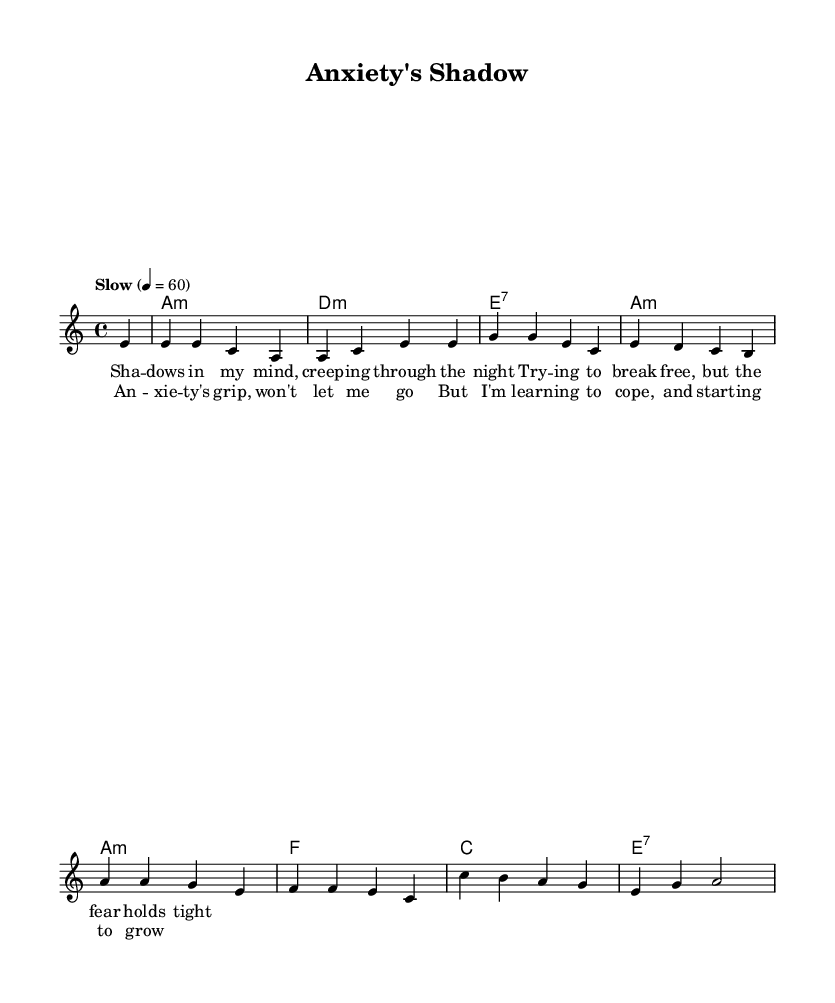What is the key signature of this music? The key signature in the sheet music is indicated at the beginning of the piece. As the piece is in A minor, which is the relative minor of C major, it has no sharps or flats.
Answer: A minor What is the time signature of the piece? The time signature is shown after the key signature, and it defines how many beats are in each measure. In this case, it is 4/4, meaning each measure has four beats.
Answer: 4/4 What is the tempo marking for this music? The tempo marking is indicated at the beginning, specifying how fast the music should be played. Here, it states "Slow" with a tempo of 60 beats per minute, which sets the overall mood of the piece.
Answer: Slow, 60 How many measures are in the score? To find the number of measures, you count the distinct groups of notes and rests that are separated by bar lines in the score. This specific piece has eight measures.
Answer: 8 What is the primary theme of the lyrics? The lyrics express feelings related to anxiety, highlighting emotional struggles that resonate with individuals who have anxiety disorders. The theme revolves around facing and coping with anxiety.
Answer: Coping with anxiety What chords are used in the harmonic progression? The harmony section lists the chords played alongside the melody. This piece features A minor, D minor, E seventh, F, and C chords. By looking at the chord symbols, we can identify this progression.
Answer: A minor, D minor, E seventh, F, C What element of blues music is prominent in this piece? A key characteristic of blues music is the exploration of deep emotional content and storytelling related to personal struggles. In this piece, the focus on mental health and the personal narrative aligns well with the blues genre.
Answer: Emotional expression 